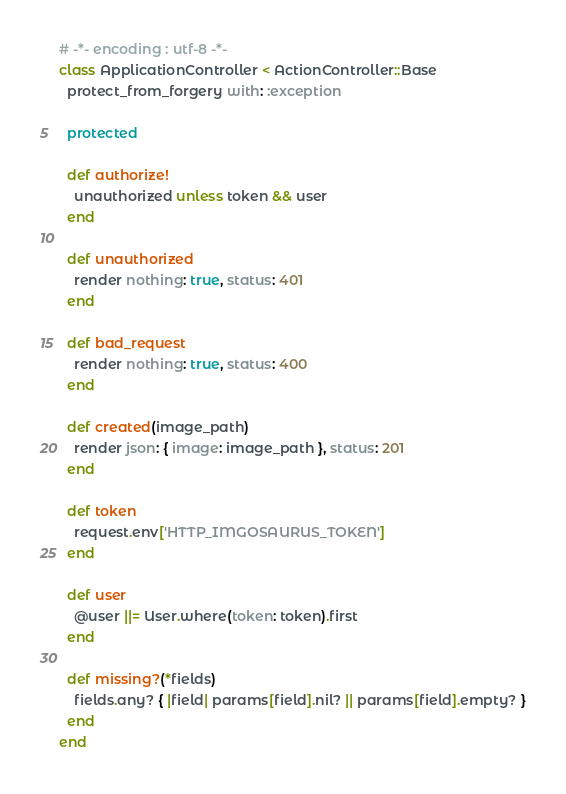Convert code to text. <code><loc_0><loc_0><loc_500><loc_500><_Ruby_># -*- encoding : utf-8 -*-
class ApplicationController < ActionController::Base
  protect_from_forgery with: :exception

  protected

  def authorize!
    unauthorized unless token && user
  end

  def unauthorized
    render nothing: true, status: 401
  end

  def bad_request
    render nothing: true, status: 400
  end

  def created(image_path)
    render json: { image: image_path }, status: 201
  end

  def token
    request.env['HTTP_IMGOSAURUS_TOKEN']
  end

  def user
    @user ||= User.where(token: token).first
  end

  def missing?(*fields)
    fields.any? { |field| params[field].nil? || params[field].empty? }
  end
end
</code> 